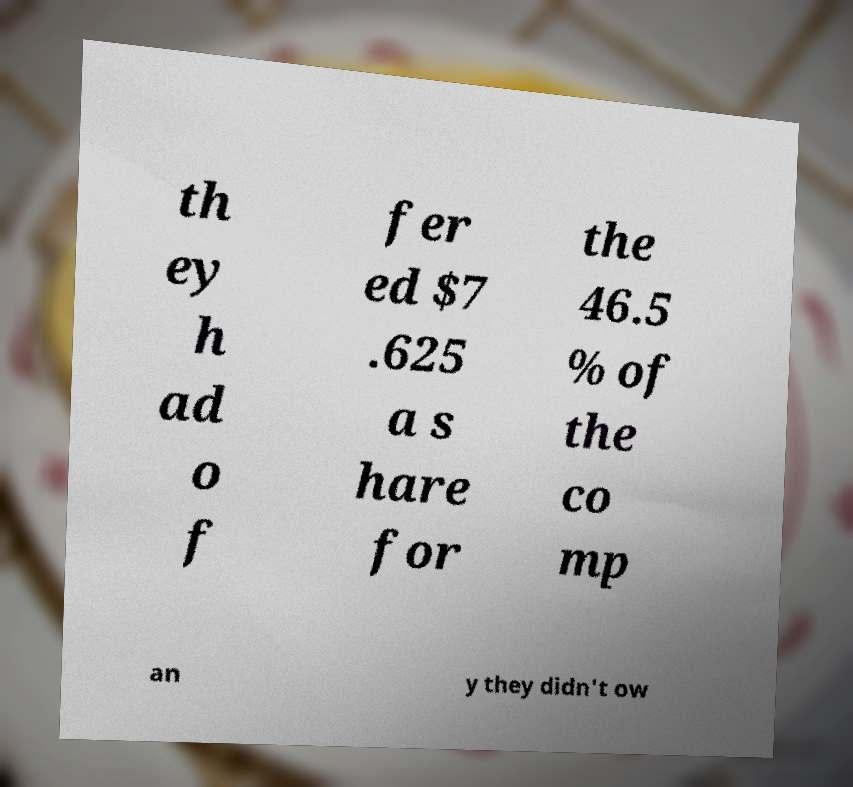Can you read and provide the text displayed in the image?This photo seems to have some interesting text. Can you extract and type it out for me? th ey h ad o f fer ed $7 .625 a s hare for the 46.5 % of the co mp an y they didn't ow 